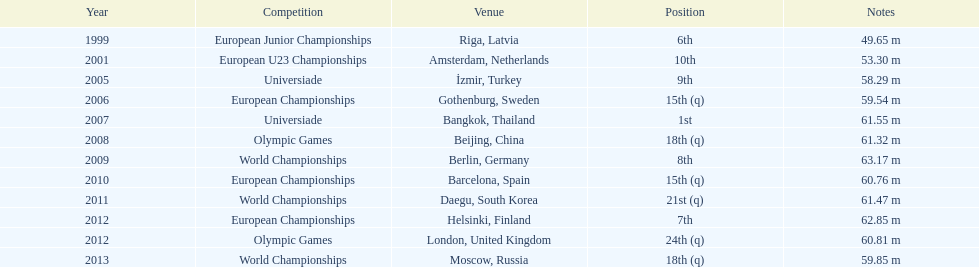What was the last competition he was in before the 2012 olympics? European Championships. 